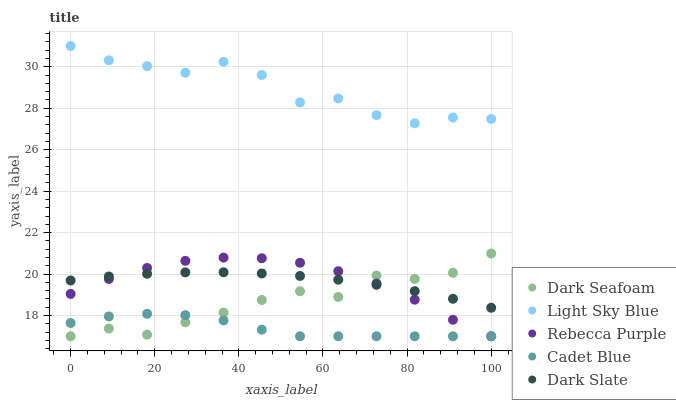Does Cadet Blue have the minimum area under the curve?
Answer yes or no. Yes. Does Light Sky Blue have the maximum area under the curve?
Answer yes or no. Yes. Does Dark Slate have the minimum area under the curve?
Answer yes or no. No. Does Dark Slate have the maximum area under the curve?
Answer yes or no. No. Is Dark Slate the smoothest?
Answer yes or no. Yes. Is Light Sky Blue the roughest?
Answer yes or no. Yes. Is Dark Seafoam the smoothest?
Answer yes or no. No. Is Dark Seafoam the roughest?
Answer yes or no. No. Does Cadet Blue have the lowest value?
Answer yes or no. Yes. Does Dark Slate have the lowest value?
Answer yes or no. No. Does Light Sky Blue have the highest value?
Answer yes or no. Yes. Does Dark Slate have the highest value?
Answer yes or no. No. Is Dark Seafoam less than Light Sky Blue?
Answer yes or no. Yes. Is Light Sky Blue greater than Dark Slate?
Answer yes or no. Yes. Does Rebecca Purple intersect Dark Slate?
Answer yes or no. Yes. Is Rebecca Purple less than Dark Slate?
Answer yes or no. No. Is Rebecca Purple greater than Dark Slate?
Answer yes or no. No. Does Dark Seafoam intersect Light Sky Blue?
Answer yes or no. No. 